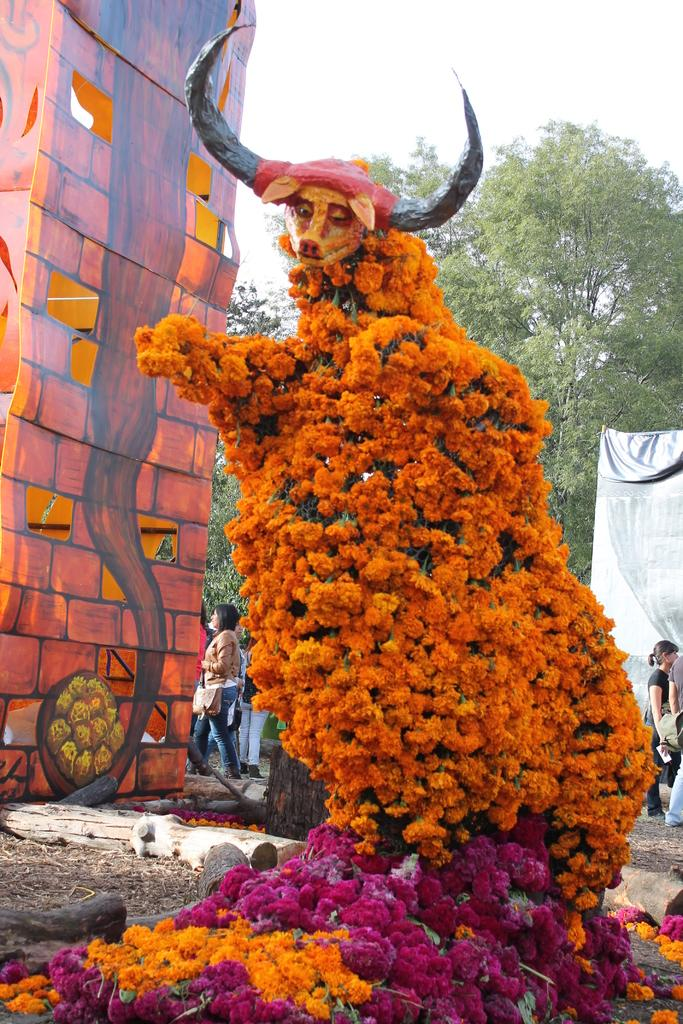What is the main subject in the image? There is a statue in the image. How is the statue decorated? The statue is decorated with flowers. What else can be seen in the image besides the statue? There is a banner, a board, a group of people, trees, and the sky visible in the image. What design does the toad have on its back in the image? There is no toad present in the image, so it is not possible to answer that question. 